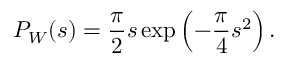<formula> <loc_0><loc_0><loc_500><loc_500>P _ { W } ( s ) = \frac { \pi } { 2 } s \exp \left ( - \frac { \pi } { 4 } s ^ { 2 } \right ) .</formula> 